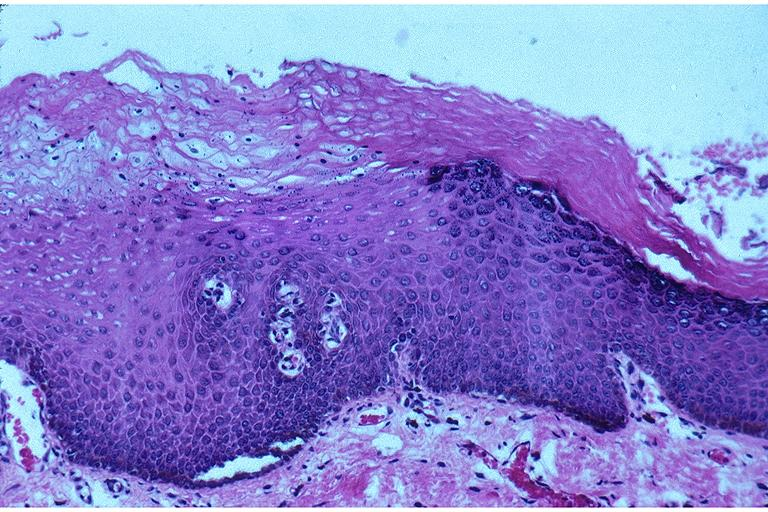what is present?
Answer the question using a single word or phrase. Oral 